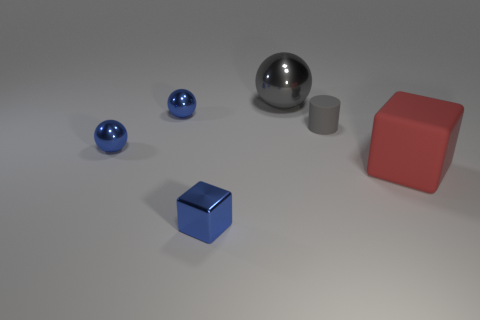Are there any other things that have the same shape as the small gray rubber object?
Offer a terse response. No. Does the tiny rubber cylinder have the same color as the large rubber block?
Your answer should be very brief. No. What number of red rubber things are right of the big rubber cube?
Keep it short and to the point. 0. Are there any big brown cubes?
Your answer should be compact. No. How big is the metallic sphere that is right of the blue object that is in front of the rubber thing that is right of the tiny gray thing?
Your answer should be compact. Large. How many other objects are the same size as the gray sphere?
Offer a very short reply. 1. There is a gray cylinder on the right side of the blue block; what size is it?
Offer a very short reply. Small. Are there any other things that have the same color as the small metallic block?
Offer a very short reply. Yes. Are the tiny thing in front of the red block and the gray cylinder made of the same material?
Your answer should be compact. No. How many things are both left of the tiny block and on the right side of the big metallic thing?
Your answer should be compact. 0. 